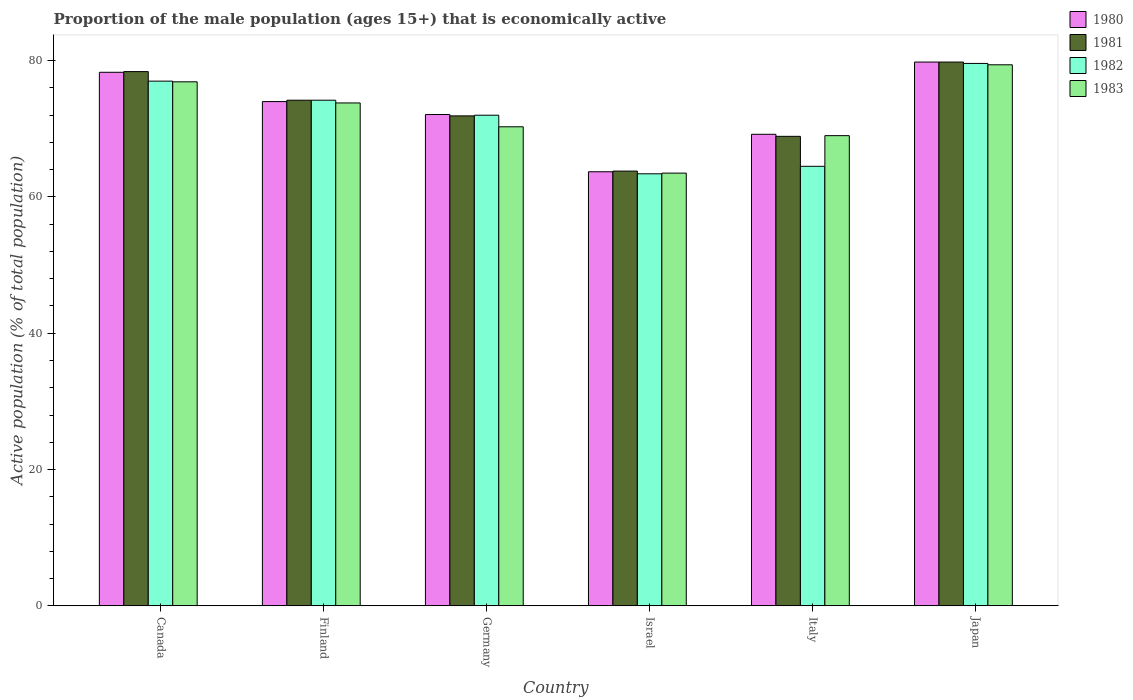How many groups of bars are there?
Your answer should be compact. 6. Are the number of bars on each tick of the X-axis equal?
Offer a terse response. Yes. How many bars are there on the 1st tick from the left?
Keep it short and to the point. 4. What is the label of the 4th group of bars from the left?
Make the answer very short. Israel. What is the proportion of the male population that is economically active in 1980 in Canada?
Offer a very short reply. 78.3. Across all countries, what is the maximum proportion of the male population that is economically active in 1982?
Your answer should be very brief. 79.6. Across all countries, what is the minimum proportion of the male population that is economically active in 1980?
Give a very brief answer. 63.7. In which country was the proportion of the male population that is economically active in 1983 maximum?
Give a very brief answer. Japan. In which country was the proportion of the male population that is economically active in 1982 minimum?
Give a very brief answer. Israel. What is the total proportion of the male population that is economically active in 1981 in the graph?
Provide a short and direct response. 437. What is the difference between the proportion of the male population that is economically active in 1981 in Canada and that in Israel?
Give a very brief answer. 14.6. What is the difference between the proportion of the male population that is economically active in 1981 in Germany and the proportion of the male population that is economically active in 1983 in Finland?
Offer a very short reply. -1.9. What is the average proportion of the male population that is economically active in 1983 per country?
Offer a very short reply. 72.15. What is the difference between the proportion of the male population that is economically active of/in 1983 and proportion of the male population that is economically active of/in 1980 in Italy?
Your answer should be very brief. -0.2. What is the ratio of the proportion of the male population that is economically active in 1980 in Canada to that in Israel?
Keep it short and to the point. 1.23. Is the proportion of the male population that is economically active in 1981 in Finland less than that in Italy?
Ensure brevity in your answer.  No. Is the difference between the proportion of the male population that is economically active in 1983 in Canada and Israel greater than the difference between the proportion of the male population that is economically active in 1980 in Canada and Israel?
Your response must be concise. No. What is the difference between the highest and the second highest proportion of the male population that is economically active in 1982?
Your response must be concise. -2.8. What is the difference between the highest and the lowest proportion of the male population that is economically active in 1981?
Keep it short and to the point. 16. In how many countries, is the proportion of the male population that is economically active in 1980 greater than the average proportion of the male population that is economically active in 1980 taken over all countries?
Your answer should be very brief. 3. Is the sum of the proportion of the male population that is economically active in 1983 in Italy and Japan greater than the maximum proportion of the male population that is economically active in 1982 across all countries?
Make the answer very short. Yes. Is it the case that in every country, the sum of the proportion of the male population that is economically active in 1983 and proportion of the male population that is economically active in 1980 is greater than the proportion of the male population that is economically active in 1982?
Make the answer very short. Yes. How many countries are there in the graph?
Give a very brief answer. 6. Does the graph contain any zero values?
Provide a short and direct response. No. Does the graph contain grids?
Ensure brevity in your answer.  No. How many legend labels are there?
Provide a succinct answer. 4. What is the title of the graph?
Your answer should be compact. Proportion of the male population (ages 15+) that is economically active. What is the label or title of the X-axis?
Your response must be concise. Country. What is the label or title of the Y-axis?
Your answer should be compact. Active population (% of total population). What is the Active population (% of total population) in 1980 in Canada?
Make the answer very short. 78.3. What is the Active population (% of total population) in 1981 in Canada?
Offer a terse response. 78.4. What is the Active population (% of total population) in 1983 in Canada?
Give a very brief answer. 76.9. What is the Active population (% of total population) in 1981 in Finland?
Offer a terse response. 74.2. What is the Active population (% of total population) in 1982 in Finland?
Offer a very short reply. 74.2. What is the Active population (% of total population) of 1983 in Finland?
Offer a very short reply. 73.8. What is the Active population (% of total population) in 1980 in Germany?
Make the answer very short. 72.1. What is the Active population (% of total population) in 1981 in Germany?
Offer a very short reply. 71.9. What is the Active population (% of total population) of 1982 in Germany?
Ensure brevity in your answer.  72. What is the Active population (% of total population) in 1983 in Germany?
Give a very brief answer. 70.3. What is the Active population (% of total population) of 1980 in Israel?
Your answer should be very brief. 63.7. What is the Active population (% of total population) of 1981 in Israel?
Ensure brevity in your answer.  63.8. What is the Active population (% of total population) of 1982 in Israel?
Make the answer very short. 63.4. What is the Active population (% of total population) in 1983 in Israel?
Your answer should be compact. 63.5. What is the Active population (% of total population) in 1980 in Italy?
Ensure brevity in your answer.  69.2. What is the Active population (% of total population) in 1981 in Italy?
Make the answer very short. 68.9. What is the Active population (% of total population) in 1982 in Italy?
Your answer should be very brief. 64.5. What is the Active population (% of total population) of 1980 in Japan?
Offer a terse response. 79.8. What is the Active population (% of total population) of 1981 in Japan?
Provide a short and direct response. 79.8. What is the Active population (% of total population) in 1982 in Japan?
Offer a terse response. 79.6. What is the Active population (% of total population) of 1983 in Japan?
Provide a short and direct response. 79.4. Across all countries, what is the maximum Active population (% of total population) in 1980?
Offer a very short reply. 79.8. Across all countries, what is the maximum Active population (% of total population) in 1981?
Make the answer very short. 79.8. Across all countries, what is the maximum Active population (% of total population) in 1982?
Your answer should be compact. 79.6. Across all countries, what is the maximum Active population (% of total population) of 1983?
Ensure brevity in your answer.  79.4. Across all countries, what is the minimum Active population (% of total population) of 1980?
Provide a short and direct response. 63.7. Across all countries, what is the minimum Active population (% of total population) of 1981?
Your answer should be compact. 63.8. Across all countries, what is the minimum Active population (% of total population) of 1982?
Offer a terse response. 63.4. Across all countries, what is the minimum Active population (% of total population) of 1983?
Your answer should be very brief. 63.5. What is the total Active population (% of total population) in 1980 in the graph?
Offer a terse response. 437.1. What is the total Active population (% of total population) of 1981 in the graph?
Give a very brief answer. 437. What is the total Active population (% of total population) of 1982 in the graph?
Make the answer very short. 430.7. What is the total Active population (% of total population) of 1983 in the graph?
Keep it short and to the point. 432.9. What is the difference between the Active population (% of total population) in 1983 in Canada and that in Finland?
Your answer should be compact. 3.1. What is the difference between the Active population (% of total population) of 1981 in Canada and that in Germany?
Provide a succinct answer. 6.5. What is the difference between the Active population (% of total population) of 1982 in Canada and that in Germany?
Provide a short and direct response. 5. What is the difference between the Active population (% of total population) of 1983 in Canada and that in Germany?
Make the answer very short. 6.6. What is the difference between the Active population (% of total population) of 1980 in Canada and that in Israel?
Ensure brevity in your answer.  14.6. What is the difference between the Active population (% of total population) in 1983 in Canada and that in Israel?
Ensure brevity in your answer.  13.4. What is the difference between the Active population (% of total population) in 1981 in Canada and that in Italy?
Ensure brevity in your answer.  9.5. What is the difference between the Active population (% of total population) in 1981 in Canada and that in Japan?
Give a very brief answer. -1.4. What is the difference between the Active population (% of total population) of 1982 in Canada and that in Japan?
Ensure brevity in your answer.  -2.6. What is the difference between the Active population (% of total population) in 1980 in Finland and that in Germany?
Give a very brief answer. 1.9. What is the difference between the Active population (% of total population) in 1982 in Finland and that in Germany?
Offer a terse response. 2.2. What is the difference between the Active population (% of total population) of 1980 in Finland and that in Israel?
Your answer should be compact. 10.3. What is the difference between the Active population (% of total population) in 1981 in Finland and that in Israel?
Keep it short and to the point. 10.4. What is the difference between the Active population (% of total population) of 1980 in Finland and that in Japan?
Ensure brevity in your answer.  -5.8. What is the difference between the Active population (% of total population) of 1981 in Finland and that in Japan?
Keep it short and to the point. -5.6. What is the difference between the Active population (% of total population) of 1981 in Germany and that in Israel?
Your answer should be very brief. 8.1. What is the difference between the Active population (% of total population) in 1983 in Germany and that in Israel?
Give a very brief answer. 6.8. What is the difference between the Active population (% of total population) in 1981 in Germany and that in Italy?
Give a very brief answer. 3. What is the difference between the Active population (% of total population) of 1980 in Germany and that in Japan?
Offer a terse response. -7.7. What is the difference between the Active population (% of total population) in 1981 in Germany and that in Japan?
Your response must be concise. -7.9. What is the difference between the Active population (% of total population) in 1983 in Germany and that in Japan?
Provide a short and direct response. -9.1. What is the difference between the Active population (% of total population) in 1982 in Israel and that in Italy?
Your response must be concise. -1.1. What is the difference between the Active population (% of total population) in 1980 in Israel and that in Japan?
Your answer should be very brief. -16.1. What is the difference between the Active population (% of total population) of 1981 in Israel and that in Japan?
Keep it short and to the point. -16. What is the difference between the Active population (% of total population) of 1982 in Israel and that in Japan?
Make the answer very short. -16.2. What is the difference between the Active population (% of total population) in 1983 in Israel and that in Japan?
Give a very brief answer. -15.9. What is the difference between the Active population (% of total population) in 1980 in Italy and that in Japan?
Your answer should be very brief. -10.6. What is the difference between the Active population (% of total population) of 1982 in Italy and that in Japan?
Offer a very short reply. -15.1. What is the difference between the Active population (% of total population) in 1980 in Canada and the Active population (% of total population) in 1982 in Finland?
Your answer should be very brief. 4.1. What is the difference between the Active population (% of total population) of 1980 in Canada and the Active population (% of total population) of 1983 in Finland?
Keep it short and to the point. 4.5. What is the difference between the Active population (% of total population) in 1980 in Canada and the Active population (% of total population) in 1983 in Germany?
Your answer should be very brief. 8. What is the difference between the Active population (% of total population) of 1980 in Canada and the Active population (% of total population) of 1981 in Israel?
Your answer should be compact. 14.5. What is the difference between the Active population (% of total population) in 1980 in Canada and the Active population (% of total population) in 1982 in Israel?
Provide a succinct answer. 14.9. What is the difference between the Active population (% of total population) in 1980 in Canada and the Active population (% of total population) in 1983 in Israel?
Give a very brief answer. 14.8. What is the difference between the Active population (% of total population) in 1982 in Canada and the Active population (% of total population) in 1983 in Israel?
Make the answer very short. 13.5. What is the difference between the Active population (% of total population) of 1980 in Canada and the Active population (% of total population) of 1981 in Italy?
Provide a short and direct response. 9.4. What is the difference between the Active population (% of total population) of 1980 in Canada and the Active population (% of total population) of 1981 in Japan?
Offer a terse response. -1.5. What is the difference between the Active population (% of total population) in 1982 in Canada and the Active population (% of total population) in 1983 in Japan?
Make the answer very short. -2.4. What is the difference between the Active population (% of total population) of 1980 in Finland and the Active population (% of total population) of 1982 in Germany?
Your answer should be very brief. 2. What is the difference between the Active population (% of total population) in 1980 in Finland and the Active population (% of total population) in 1983 in Germany?
Offer a very short reply. 3.7. What is the difference between the Active population (% of total population) of 1981 in Finland and the Active population (% of total population) of 1983 in Germany?
Your answer should be very brief. 3.9. What is the difference between the Active population (% of total population) of 1982 in Finland and the Active population (% of total population) of 1983 in Germany?
Provide a short and direct response. 3.9. What is the difference between the Active population (% of total population) of 1980 in Finland and the Active population (% of total population) of 1983 in Israel?
Offer a terse response. 10.5. What is the difference between the Active population (% of total population) in 1982 in Finland and the Active population (% of total population) in 1983 in Israel?
Provide a succinct answer. 10.7. What is the difference between the Active population (% of total population) in 1980 in Finland and the Active population (% of total population) in 1983 in Italy?
Keep it short and to the point. 5. What is the difference between the Active population (% of total population) in 1982 in Finland and the Active population (% of total population) in 1983 in Italy?
Your answer should be very brief. 5.2. What is the difference between the Active population (% of total population) of 1980 in Finland and the Active population (% of total population) of 1981 in Japan?
Your response must be concise. -5.8. What is the difference between the Active population (% of total population) in 1980 in Finland and the Active population (% of total population) in 1983 in Japan?
Provide a succinct answer. -5.4. What is the difference between the Active population (% of total population) in 1981 in Finland and the Active population (% of total population) in 1982 in Japan?
Keep it short and to the point. -5.4. What is the difference between the Active population (% of total population) of 1981 in Finland and the Active population (% of total population) of 1983 in Japan?
Keep it short and to the point. -5.2. What is the difference between the Active population (% of total population) of 1982 in Germany and the Active population (% of total population) of 1983 in Israel?
Your answer should be compact. 8.5. What is the difference between the Active population (% of total population) of 1980 in Germany and the Active population (% of total population) of 1981 in Italy?
Your answer should be very brief. 3.2. What is the difference between the Active population (% of total population) of 1981 in Germany and the Active population (% of total population) of 1982 in Italy?
Ensure brevity in your answer.  7.4. What is the difference between the Active population (% of total population) of 1981 in Germany and the Active population (% of total population) of 1983 in Italy?
Keep it short and to the point. 2.9. What is the difference between the Active population (% of total population) in 1980 in Germany and the Active population (% of total population) in 1982 in Japan?
Ensure brevity in your answer.  -7.5. What is the difference between the Active population (% of total population) in 1980 in Germany and the Active population (% of total population) in 1983 in Japan?
Your answer should be very brief. -7.3. What is the difference between the Active population (% of total population) of 1981 in Germany and the Active population (% of total population) of 1983 in Japan?
Provide a short and direct response. -7.5. What is the difference between the Active population (% of total population) in 1980 in Israel and the Active population (% of total population) in 1982 in Italy?
Give a very brief answer. -0.8. What is the difference between the Active population (% of total population) of 1980 in Israel and the Active population (% of total population) of 1983 in Italy?
Give a very brief answer. -5.3. What is the difference between the Active population (% of total population) in 1981 in Israel and the Active population (% of total population) in 1982 in Italy?
Give a very brief answer. -0.7. What is the difference between the Active population (% of total population) in 1981 in Israel and the Active population (% of total population) in 1983 in Italy?
Your answer should be compact. -5.2. What is the difference between the Active population (% of total population) in 1982 in Israel and the Active population (% of total population) in 1983 in Italy?
Provide a succinct answer. -5.6. What is the difference between the Active population (% of total population) in 1980 in Israel and the Active population (% of total population) in 1981 in Japan?
Offer a terse response. -16.1. What is the difference between the Active population (% of total population) of 1980 in Israel and the Active population (% of total population) of 1982 in Japan?
Offer a very short reply. -15.9. What is the difference between the Active population (% of total population) of 1980 in Israel and the Active population (% of total population) of 1983 in Japan?
Provide a succinct answer. -15.7. What is the difference between the Active population (% of total population) of 1981 in Israel and the Active population (% of total population) of 1982 in Japan?
Your answer should be compact. -15.8. What is the difference between the Active population (% of total population) in 1981 in Israel and the Active population (% of total population) in 1983 in Japan?
Ensure brevity in your answer.  -15.6. What is the difference between the Active population (% of total population) of 1982 in Israel and the Active population (% of total population) of 1983 in Japan?
Your answer should be compact. -16. What is the difference between the Active population (% of total population) of 1980 in Italy and the Active population (% of total population) of 1981 in Japan?
Make the answer very short. -10.6. What is the difference between the Active population (% of total population) of 1980 in Italy and the Active population (% of total population) of 1982 in Japan?
Ensure brevity in your answer.  -10.4. What is the difference between the Active population (% of total population) in 1981 in Italy and the Active population (% of total population) in 1982 in Japan?
Offer a terse response. -10.7. What is the difference between the Active population (% of total population) in 1981 in Italy and the Active population (% of total population) in 1983 in Japan?
Keep it short and to the point. -10.5. What is the difference between the Active population (% of total population) of 1982 in Italy and the Active population (% of total population) of 1983 in Japan?
Offer a very short reply. -14.9. What is the average Active population (% of total population) in 1980 per country?
Provide a short and direct response. 72.85. What is the average Active population (% of total population) in 1981 per country?
Offer a very short reply. 72.83. What is the average Active population (% of total population) of 1982 per country?
Make the answer very short. 71.78. What is the average Active population (% of total population) in 1983 per country?
Keep it short and to the point. 72.15. What is the difference between the Active population (% of total population) of 1980 and Active population (% of total population) of 1981 in Canada?
Offer a very short reply. -0.1. What is the difference between the Active population (% of total population) in 1981 and Active population (% of total population) in 1983 in Canada?
Make the answer very short. 1.5. What is the difference between the Active population (% of total population) in 1981 and Active population (% of total population) in 1983 in Finland?
Offer a very short reply. 0.4. What is the difference between the Active population (% of total population) in 1982 and Active population (% of total population) in 1983 in Finland?
Your answer should be compact. 0.4. What is the difference between the Active population (% of total population) of 1980 and Active population (% of total population) of 1981 in Germany?
Keep it short and to the point. 0.2. What is the difference between the Active population (% of total population) of 1981 and Active population (% of total population) of 1982 in Germany?
Your answer should be compact. -0.1. What is the difference between the Active population (% of total population) of 1982 and Active population (% of total population) of 1983 in Germany?
Offer a terse response. 1.7. What is the difference between the Active population (% of total population) of 1980 and Active population (% of total population) of 1983 in Israel?
Give a very brief answer. 0.2. What is the difference between the Active population (% of total population) of 1980 and Active population (% of total population) of 1982 in Italy?
Provide a succinct answer. 4.7. What is the difference between the Active population (% of total population) in 1981 and Active population (% of total population) in 1983 in Italy?
Offer a very short reply. -0.1. What is the difference between the Active population (% of total population) of 1982 and Active population (% of total population) of 1983 in Italy?
Keep it short and to the point. -4.5. What is the difference between the Active population (% of total population) of 1980 and Active population (% of total population) of 1981 in Japan?
Give a very brief answer. 0. What is the difference between the Active population (% of total population) in 1980 and Active population (% of total population) in 1983 in Japan?
Your response must be concise. 0.4. What is the difference between the Active population (% of total population) in 1981 and Active population (% of total population) in 1982 in Japan?
Provide a succinct answer. 0.2. What is the ratio of the Active population (% of total population) of 1980 in Canada to that in Finland?
Keep it short and to the point. 1.06. What is the ratio of the Active population (% of total population) in 1981 in Canada to that in Finland?
Provide a short and direct response. 1.06. What is the ratio of the Active population (% of total population) of 1982 in Canada to that in Finland?
Make the answer very short. 1.04. What is the ratio of the Active population (% of total population) in 1983 in Canada to that in Finland?
Keep it short and to the point. 1.04. What is the ratio of the Active population (% of total population) in 1980 in Canada to that in Germany?
Your response must be concise. 1.09. What is the ratio of the Active population (% of total population) in 1981 in Canada to that in Germany?
Offer a terse response. 1.09. What is the ratio of the Active population (% of total population) in 1982 in Canada to that in Germany?
Your answer should be compact. 1.07. What is the ratio of the Active population (% of total population) in 1983 in Canada to that in Germany?
Offer a terse response. 1.09. What is the ratio of the Active population (% of total population) in 1980 in Canada to that in Israel?
Your response must be concise. 1.23. What is the ratio of the Active population (% of total population) of 1981 in Canada to that in Israel?
Your answer should be very brief. 1.23. What is the ratio of the Active population (% of total population) of 1982 in Canada to that in Israel?
Your response must be concise. 1.21. What is the ratio of the Active population (% of total population) of 1983 in Canada to that in Israel?
Keep it short and to the point. 1.21. What is the ratio of the Active population (% of total population) of 1980 in Canada to that in Italy?
Provide a short and direct response. 1.13. What is the ratio of the Active population (% of total population) of 1981 in Canada to that in Italy?
Ensure brevity in your answer.  1.14. What is the ratio of the Active population (% of total population) in 1982 in Canada to that in Italy?
Your answer should be compact. 1.19. What is the ratio of the Active population (% of total population) in 1983 in Canada to that in Italy?
Ensure brevity in your answer.  1.11. What is the ratio of the Active population (% of total population) in 1980 in Canada to that in Japan?
Your response must be concise. 0.98. What is the ratio of the Active population (% of total population) in 1981 in Canada to that in Japan?
Your answer should be compact. 0.98. What is the ratio of the Active population (% of total population) in 1982 in Canada to that in Japan?
Your response must be concise. 0.97. What is the ratio of the Active population (% of total population) of 1983 in Canada to that in Japan?
Offer a terse response. 0.97. What is the ratio of the Active population (% of total population) in 1980 in Finland to that in Germany?
Provide a succinct answer. 1.03. What is the ratio of the Active population (% of total population) of 1981 in Finland to that in Germany?
Your answer should be very brief. 1.03. What is the ratio of the Active population (% of total population) in 1982 in Finland to that in Germany?
Your answer should be very brief. 1.03. What is the ratio of the Active population (% of total population) of 1983 in Finland to that in Germany?
Offer a terse response. 1.05. What is the ratio of the Active population (% of total population) in 1980 in Finland to that in Israel?
Keep it short and to the point. 1.16. What is the ratio of the Active population (% of total population) of 1981 in Finland to that in Israel?
Offer a terse response. 1.16. What is the ratio of the Active population (% of total population) in 1982 in Finland to that in Israel?
Provide a short and direct response. 1.17. What is the ratio of the Active population (% of total population) of 1983 in Finland to that in Israel?
Provide a succinct answer. 1.16. What is the ratio of the Active population (% of total population) in 1980 in Finland to that in Italy?
Provide a succinct answer. 1.07. What is the ratio of the Active population (% of total population) of 1982 in Finland to that in Italy?
Provide a short and direct response. 1.15. What is the ratio of the Active population (% of total population) of 1983 in Finland to that in Italy?
Give a very brief answer. 1.07. What is the ratio of the Active population (% of total population) of 1980 in Finland to that in Japan?
Your answer should be very brief. 0.93. What is the ratio of the Active population (% of total population) of 1981 in Finland to that in Japan?
Give a very brief answer. 0.93. What is the ratio of the Active population (% of total population) of 1982 in Finland to that in Japan?
Offer a very short reply. 0.93. What is the ratio of the Active population (% of total population) in 1983 in Finland to that in Japan?
Your response must be concise. 0.93. What is the ratio of the Active population (% of total population) of 1980 in Germany to that in Israel?
Your answer should be very brief. 1.13. What is the ratio of the Active population (% of total population) in 1981 in Germany to that in Israel?
Provide a short and direct response. 1.13. What is the ratio of the Active population (% of total population) in 1982 in Germany to that in Israel?
Offer a terse response. 1.14. What is the ratio of the Active population (% of total population) in 1983 in Germany to that in Israel?
Your answer should be compact. 1.11. What is the ratio of the Active population (% of total population) in 1980 in Germany to that in Italy?
Offer a terse response. 1.04. What is the ratio of the Active population (% of total population) of 1981 in Germany to that in Italy?
Offer a very short reply. 1.04. What is the ratio of the Active population (% of total population) in 1982 in Germany to that in Italy?
Provide a succinct answer. 1.12. What is the ratio of the Active population (% of total population) of 1983 in Germany to that in Italy?
Your answer should be very brief. 1.02. What is the ratio of the Active population (% of total population) in 1980 in Germany to that in Japan?
Offer a terse response. 0.9. What is the ratio of the Active population (% of total population) of 1981 in Germany to that in Japan?
Your answer should be very brief. 0.9. What is the ratio of the Active population (% of total population) of 1982 in Germany to that in Japan?
Offer a very short reply. 0.9. What is the ratio of the Active population (% of total population) of 1983 in Germany to that in Japan?
Provide a short and direct response. 0.89. What is the ratio of the Active population (% of total population) in 1980 in Israel to that in Italy?
Keep it short and to the point. 0.92. What is the ratio of the Active population (% of total population) of 1981 in Israel to that in Italy?
Provide a succinct answer. 0.93. What is the ratio of the Active population (% of total population) of 1982 in Israel to that in Italy?
Your answer should be compact. 0.98. What is the ratio of the Active population (% of total population) of 1983 in Israel to that in Italy?
Make the answer very short. 0.92. What is the ratio of the Active population (% of total population) of 1980 in Israel to that in Japan?
Your answer should be very brief. 0.8. What is the ratio of the Active population (% of total population) of 1981 in Israel to that in Japan?
Your answer should be very brief. 0.8. What is the ratio of the Active population (% of total population) of 1982 in Israel to that in Japan?
Offer a terse response. 0.8. What is the ratio of the Active population (% of total population) of 1983 in Israel to that in Japan?
Make the answer very short. 0.8. What is the ratio of the Active population (% of total population) in 1980 in Italy to that in Japan?
Your answer should be compact. 0.87. What is the ratio of the Active population (% of total population) in 1981 in Italy to that in Japan?
Offer a very short reply. 0.86. What is the ratio of the Active population (% of total population) of 1982 in Italy to that in Japan?
Offer a terse response. 0.81. What is the ratio of the Active population (% of total population) of 1983 in Italy to that in Japan?
Offer a terse response. 0.87. What is the difference between the highest and the second highest Active population (% of total population) in 1981?
Give a very brief answer. 1.4. What is the difference between the highest and the second highest Active population (% of total population) in 1983?
Ensure brevity in your answer.  2.5. 